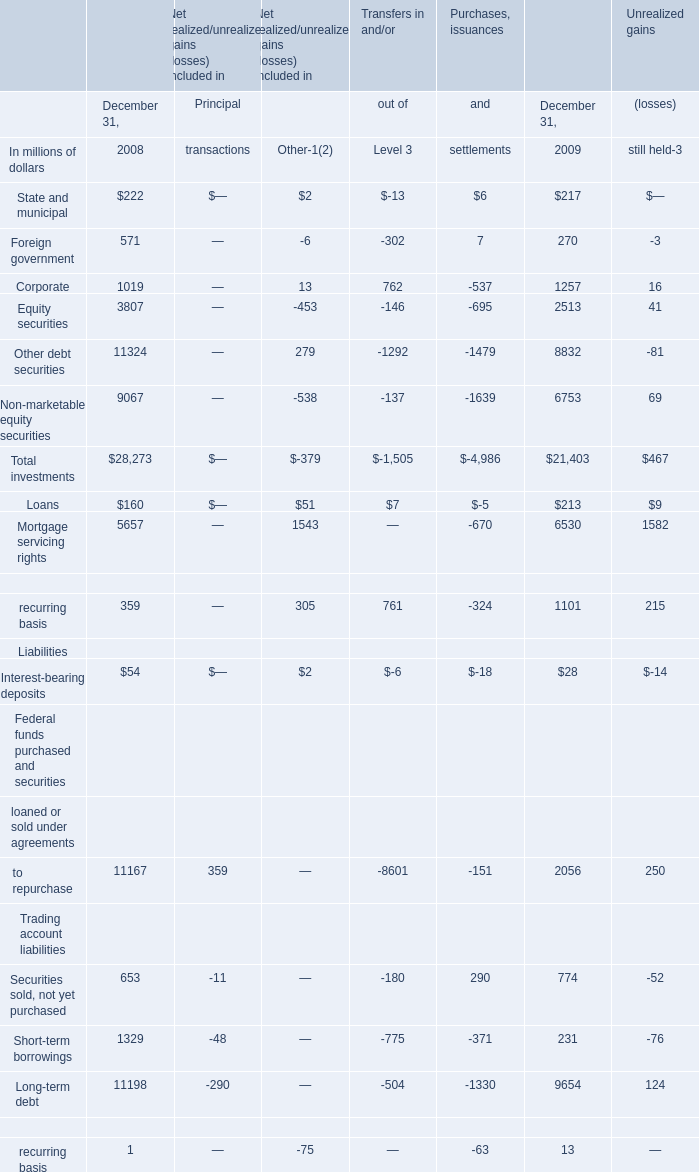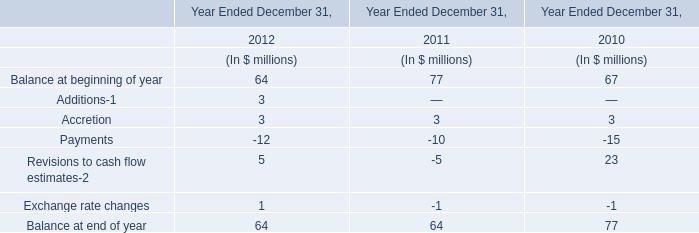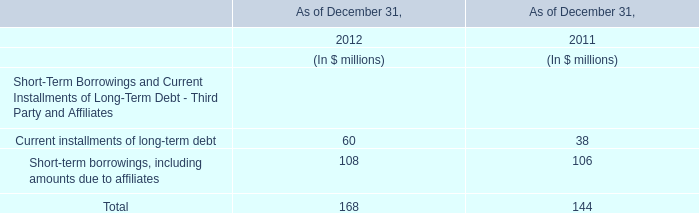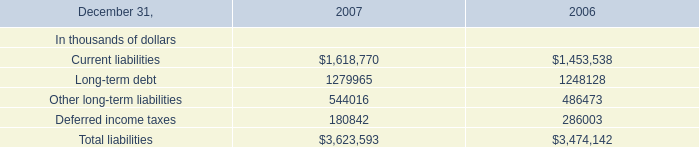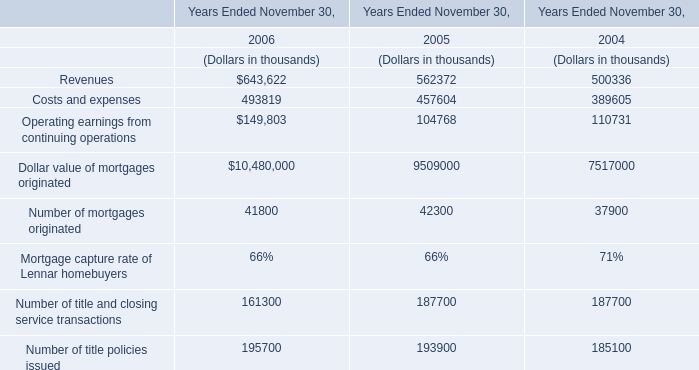What will Securities sold, not yet purchased be like in 2010 if it develops with the same increasing rate as current? (in millions of dollars) 
Computations: (774 * (1 + ((774 - 653) / 653)))
Answer: 917.42113. 